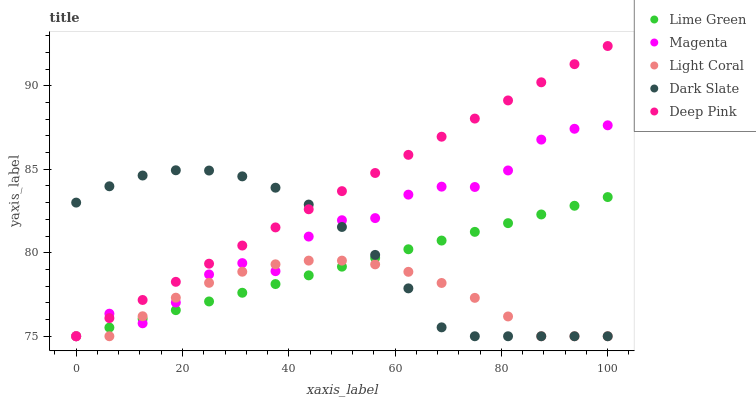Does Light Coral have the minimum area under the curve?
Answer yes or no. Yes. Does Deep Pink have the maximum area under the curve?
Answer yes or no. Yes. Does Dark Slate have the minimum area under the curve?
Answer yes or no. No. Does Dark Slate have the maximum area under the curve?
Answer yes or no. No. Is Deep Pink the smoothest?
Answer yes or no. Yes. Is Magenta the roughest?
Answer yes or no. Yes. Is Dark Slate the smoothest?
Answer yes or no. No. Is Dark Slate the roughest?
Answer yes or no. No. Does Light Coral have the lowest value?
Answer yes or no. Yes. Does Deep Pink have the highest value?
Answer yes or no. Yes. Does Dark Slate have the highest value?
Answer yes or no. No. Does Magenta intersect Light Coral?
Answer yes or no. Yes. Is Magenta less than Light Coral?
Answer yes or no. No. Is Magenta greater than Light Coral?
Answer yes or no. No. 